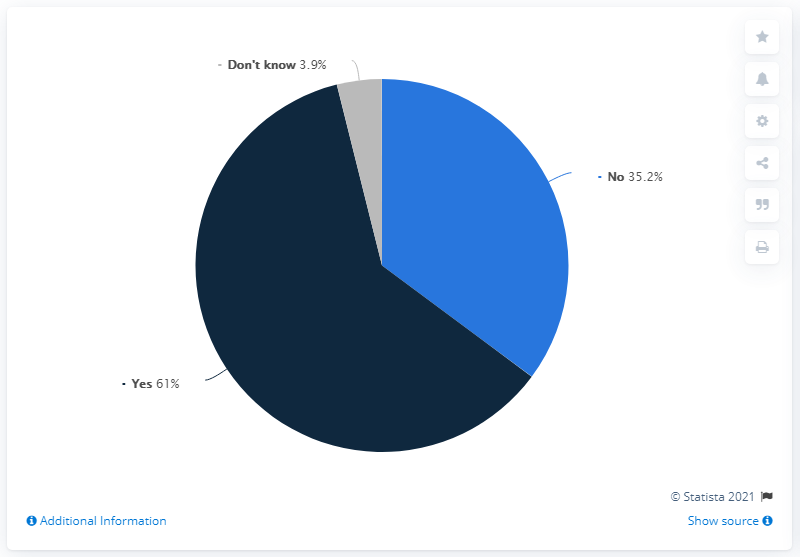Give some essential details in this illustration. According to a survey, 96.2% of people answered 'yes' and 'no' in a certain question. Out of the total number of people surveyed, 3.9% responded with 'Don't know'. 